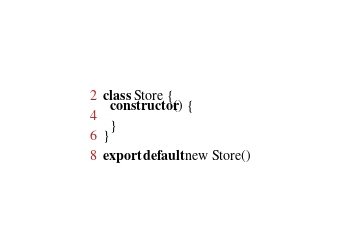Convert code to text. <code><loc_0><loc_0><loc_500><loc_500><_JavaScript_>class Store {
  constructor() {
    
  }
}

export default new Store()</code> 